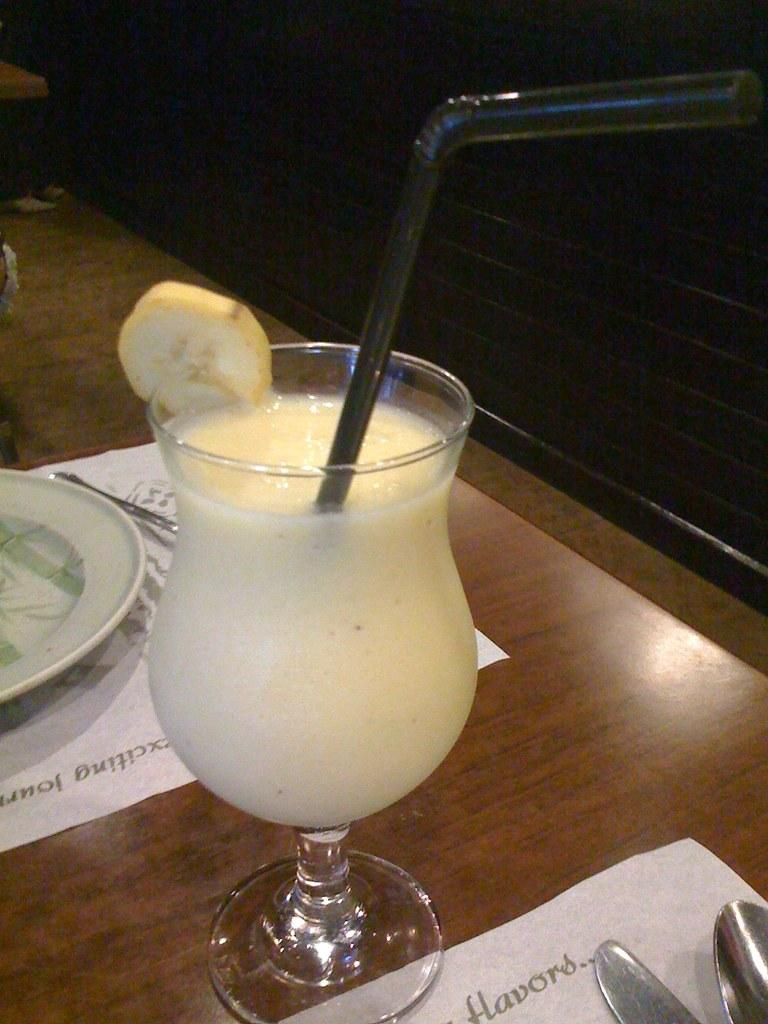What is located at the bottom of the image? There is a table at the bottom of the image. What can be found on the table? There is a glass containing a drink, a plate, a knife, a spoon, and a paper placed on the table. What might be used for eating or drinking in the image? The knife, spoon, and glass containing a drink can be used for eating or drinking. What type of sofa is visible in the image? There is no sofa present in the image. What is the weight of the paper on the table? The weight of the paper cannot be determined from the image alone. 